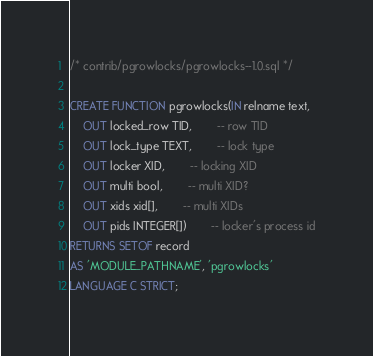Convert code to text. <code><loc_0><loc_0><loc_500><loc_500><_SQL_>/* contrib/pgrowlocks/pgrowlocks--1.0.sql */

CREATE FUNCTION pgrowlocks(IN relname text,
    OUT locked_row TID,		-- row TID
    OUT lock_type TEXT,		-- lock type
    OUT locker XID,		-- locking XID
    OUT multi bool,		-- multi XID?
    OUT xids xid[],		-- multi XIDs
    OUT pids INTEGER[])		-- locker's process id
RETURNS SETOF record
AS 'MODULE_PATHNAME', 'pgrowlocks'
LANGUAGE C STRICT;
</code> 